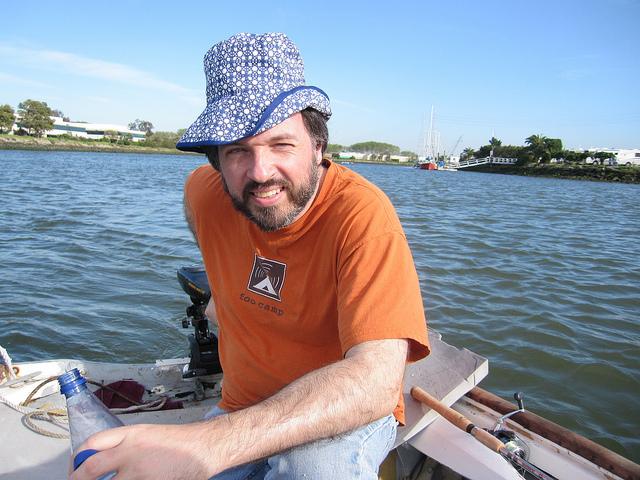Is this a cowboy hat?
Give a very brief answer. No. What hand is he holding the bottle with?
Keep it brief. Left. Is the man holding metal?
Write a very short answer. No. 